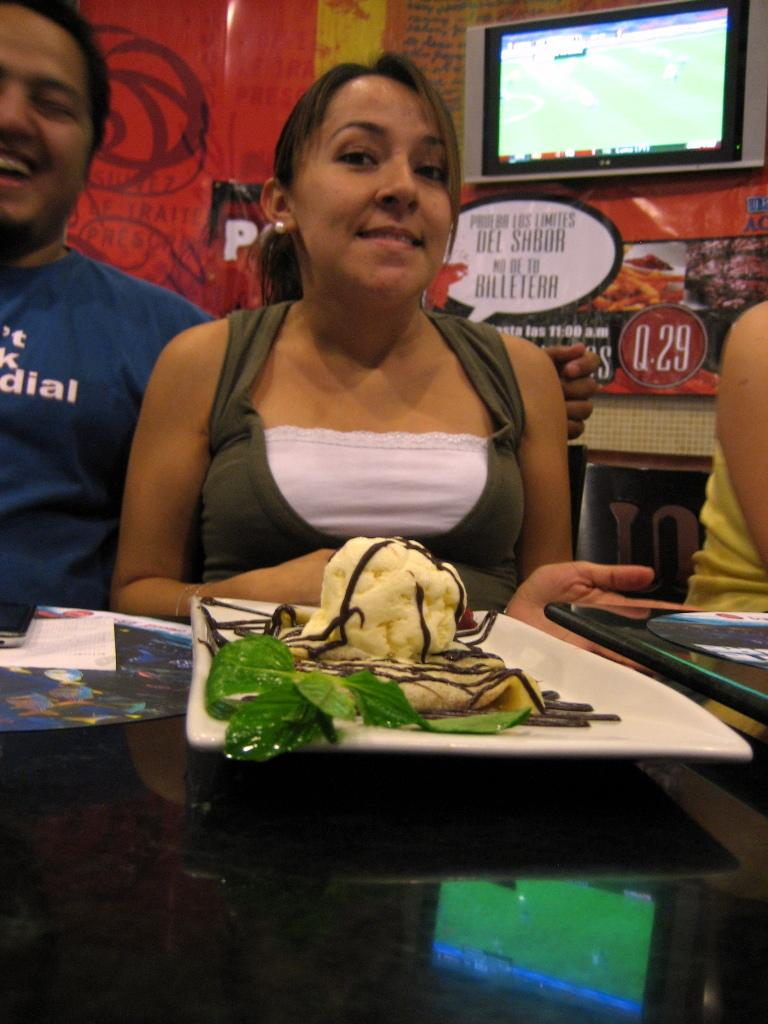Who is present in the image? There is a woman in the image. What is the woman doing in the image? The woman is sitting and smiling. What is on the table in front of the woman? There is a plate with ice cream on the table. What can be seen in the background of the image? There is a television and a wall in the background. What type of religious ceremony is taking place in the image? There is no indication of a religious ceremony in the image; it features a woman sitting and smiling with a plate of ice cream on a table. Can you hear the woman whistling in the image? There is no sound in the image, so it is impossible to determine if the woman is whistling or not. 